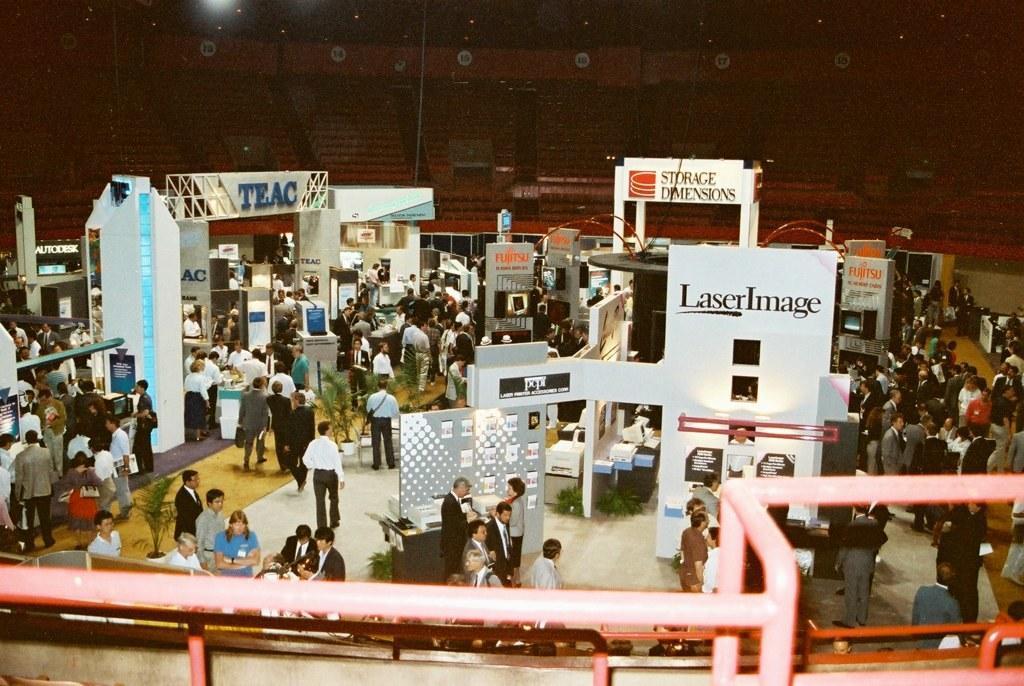Could you give a brief overview of what you see in this image? At the bottom of the image there are rods. Behind the rods there are many people and also there are many posters with few images. And also there are many posters. At the top of the image there are seats. 